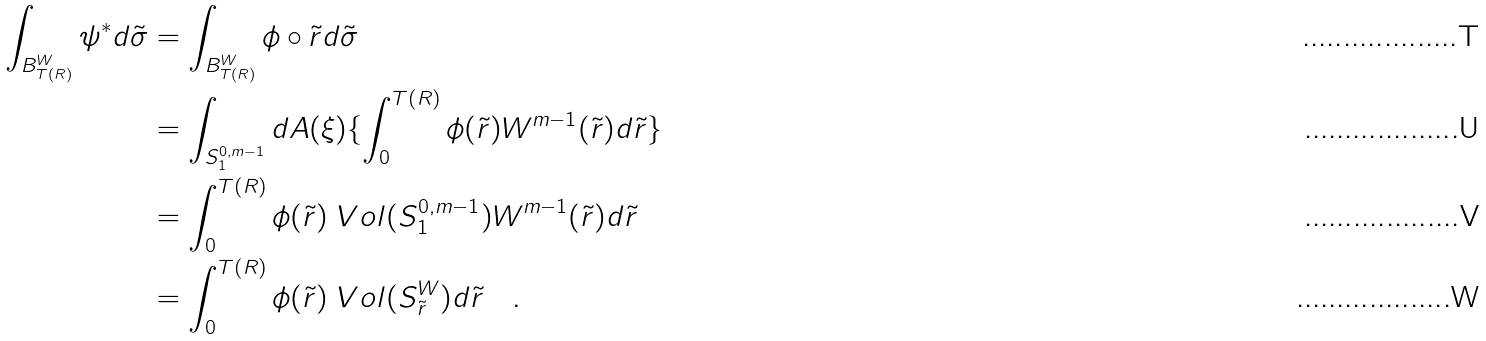<formula> <loc_0><loc_0><loc_500><loc_500>\int _ { B ^ { W } _ { T ( R ) } } \psi ^ { * } d \tilde { \sigma } & = \int _ { B ^ { W } _ { T ( R ) } } \phi \circ \tilde { r } d \tilde { \sigma } \\ & = \int _ { S ^ { 0 , m - 1 } _ { 1 } } d A ( \xi ) \{ \int _ { 0 } ^ { T ( R ) } \phi ( \tilde { r } ) W ^ { m - 1 } ( \tilde { r } ) d \tilde { r } \} \\ & = \int _ { 0 } ^ { T ( R ) } \phi ( \tilde { r } ) \ V o l ( S ^ { 0 , m - 1 } _ { 1 } ) W ^ { m - 1 } ( \tilde { r } ) d \tilde { r } \\ & = \int _ { 0 } ^ { T ( R ) } \phi ( \tilde { r } ) \ V o l ( S ^ { W } _ { \tilde { r } } ) d \tilde { r } \quad .</formula> 